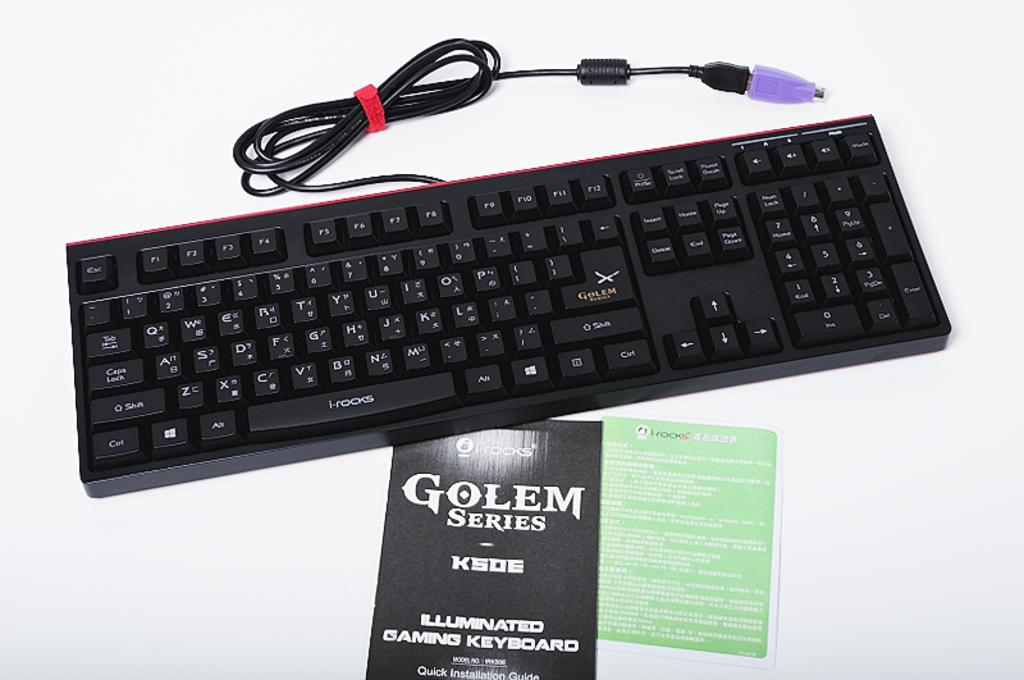<image>
Describe the image concisely. A Golem lighted game keyboard is shown with its black pamphlet. 